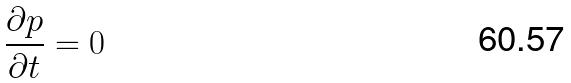Convert formula to latex. <formula><loc_0><loc_0><loc_500><loc_500>\frac { \partial p } { \partial t } = 0</formula> 